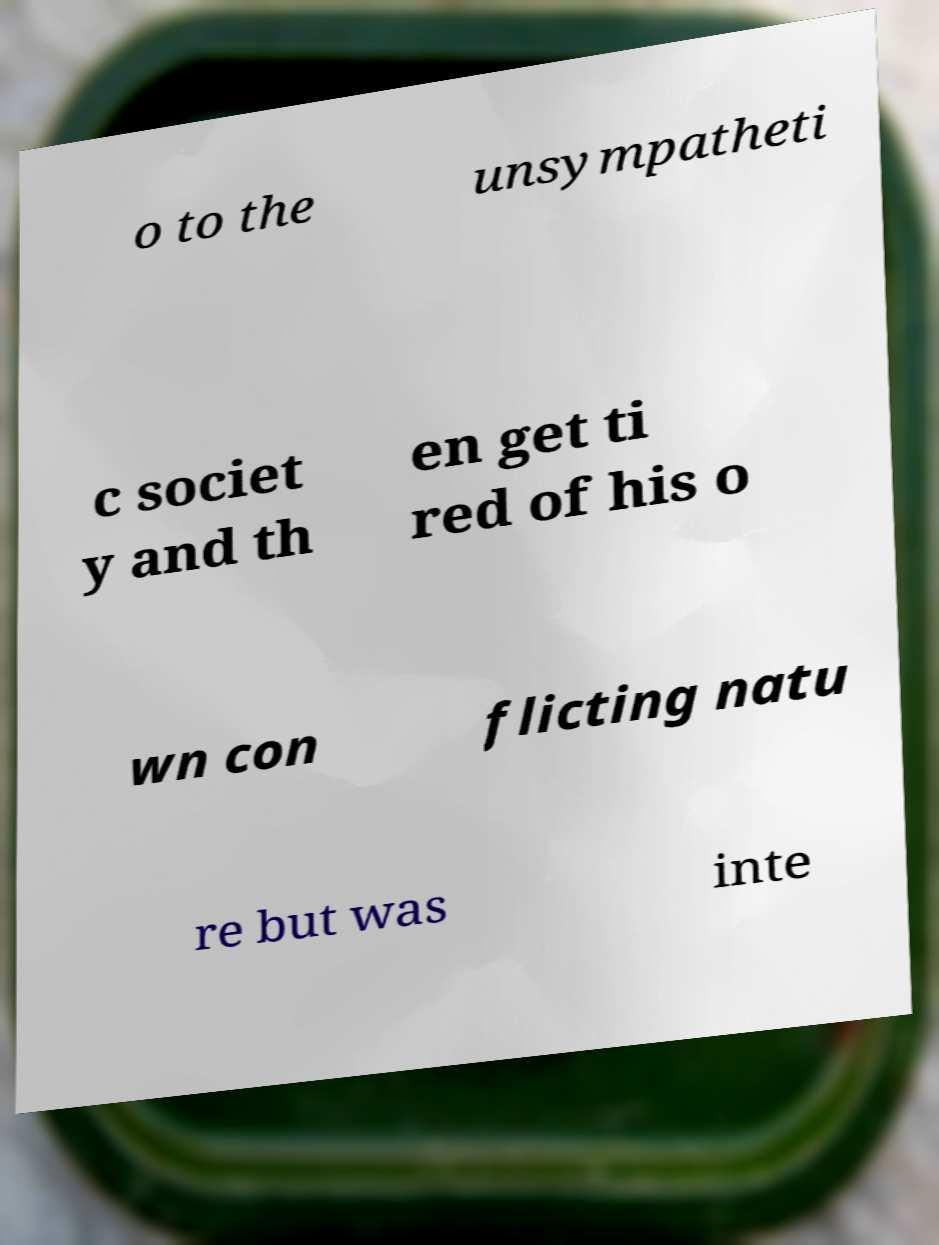For documentation purposes, I need the text within this image transcribed. Could you provide that? o to the unsympatheti c societ y and th en get ti red of his o wn con flicting natu re but was inte 